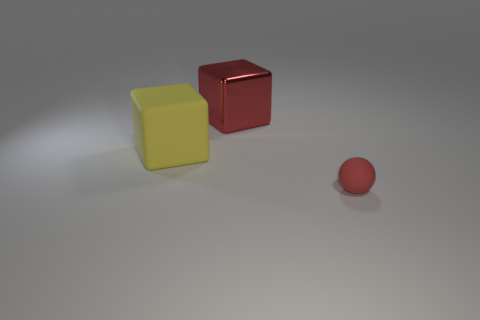Is there anything else that is the same size as the red matte object?
Your response must be concise. No. Is there anything else that has the same material as the red block?
Provide a short and direct response. No. There is a red object to the left of the small ball; does it have the same shape as the red object that is to the right of the large red object?
Provide a short and direct response. No. How many big blue metallic cylinders are there?
Provide a succinct answer. 0. There is a small red thing that is the same material as the large yellow cube; what shape is it?
Ensure brevity in your answer.  Sphere. Are there any other things that are the same color as the tiny rubber sphere?
Give a very brief answer. Yes. There is a small matte ball; is it the same color as the big object that is behind the yellow cube?
Your response must be concise. Yes. Is the number of things left of the large metallic thing less than the number of big yellow rubber cubes?
Give a very brief answer. No. What is the big block that is to the right of the rubber block made of?
Make the answer very short. Metal. What number of other objects are there of the same size as the matte block?
Keep it short and to the point. 1. 